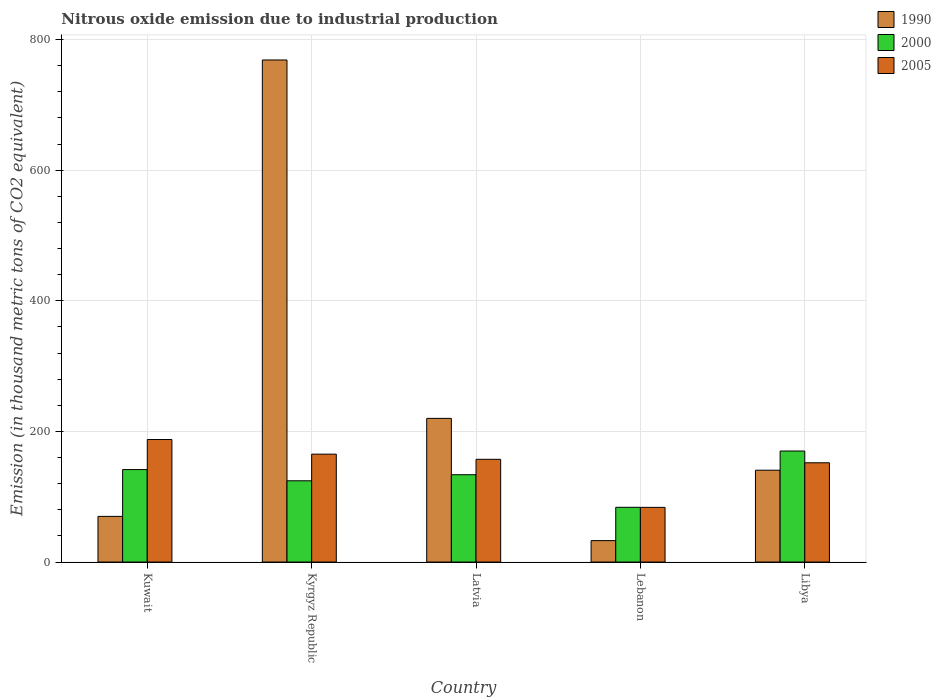Are the number of bars per tick equal to the number of legend labels?
Your answer should be compact. Yes. How many bars are there on the 3rd tick from the left?
Your answer should be very brief. 3. What is the label of the 1st group of bars from the left?
Offer a very short reply. Kuwait. What is the amount of nitrous oxide emitted in 1990 in Latvia?
Your answer should be very brief. 220. Across all countries, what is the maximum amount of nitrous oxide emitted in 1990?
Provide a succinct answer. 768.8. Across all countries, what is the minimum amount of nitrous oxide emitted in 2005?
Ensure brevity in your answer.  83.7. In which country was the amount of nitrous oxide emitted in 2005 maximum?
Give a very brief answer. Kuwait. In which country was the amount of nitrous oxide emitted in 2000 minimum?
Provide a short and direct response. Lebanon. What is the total amount of nitrous oxide emitted in 2005 in the graph?
Your answer should be compact. 745.8. What is the difference between the amount of nitrous oxide emitted in 2005 in Kyrgyz Republic and that in Lebanon?
Give a very brief answer. 81.5. What is the difference between the amount of nitrous oxide emitted in 2005 in Kyrgyz Republic and the amount of nitrous oxide emitted in 2000 in Kuwait?
Ensure brevity in your answer.  23.6. What is the average amount of nitrous oxide emitted in 2005 per country?
Give a very brief answer. 149.16. What is the difference between the amount of nitrous oxide emitted of/in 1990 and amount of nitrous oxide emitted of/in 2005 in Lebanon?
Your response must be concise. -50.9. What is the ratio of the amount of nitrous oxide emitted in 2000 in Kuwait to that in Kyrgyz Republic?
Make the answer very short. 1.14. What is the difference between the highest and the second highest amount of nitrous oxide emitted in 2000?
Offer a very short reply. 28.4. What is the difference between the highest and the lowest amount of nitrous oxide emitted in 2005?
Offer a terse response. 103.9. What does the 3rd bar from the left in Libya represents?
Your answer should be very brief. 2005. What does the 3rd bar from the right in Kuwait represents?
Provide a succinct answer. 1990. What is the difference between two consecutive major ticks on the Y-axis?
Provide a short and direct response. 200. Does the graph contain grids?
Offer a very short reply. Yes. What is the title of the graph?
Your answer should be compact. Nitrous oxide emission due to industrial production. What is the label or title of the Y-axis?
Your answer should be compact. Emission (in thousand metric tons of CO2 equivalent). What is the Emission (in thousand metric tons of CO2 equivalent) of 1990 in Kuwait?
Your answer should be compact. 69.9. What is the Emission (in thousand metric tons of CO2 equivalent) of 2000 in Kuwait?
Your answer should be compact. 141.6. What is the Emission (in thousand metric tons of CO2 equivalent) in 2005 in Kuwait?
Make the answer very short. 187.6. What is the Emission (in thousand metric tons of CO2 equivalent) in 1990 in Kyrgyz Republic?
Make the answer very short. 768.8. What is the Emission (in thousand metric tons of CO2 equivalent) of 2000 in Kyrgyz Republic?
Provide a succinct answer. 124.4. What is the Emission (in thousand metric tons of CO2 equivalent) of 2005 in Kyrgyz Republic?
Your answer should be very brief. 165.2. What is the Emission (in thousand metric tons of CO2 equivalent) in 1990 in Latvia?
Offer a terse response. 220. What is the Emission (in thousand metric tons of CO2 equivalent) of 2000 in Latvia?
Provide a succinct answer. 133.7. What is the Emission (in thousand metric tons of CO2 equivalent) of 2005 in Latvia?
Offer a very short reply. 157.3. What is the Emission (in thousand metric tons of CO2 equivalent) in 1990 in Lebanon?
Offer a very short reply. 32.8. What is the Emission (in thousand metric tons of CO2 equivalent) of 2000 in Lebanon?
Your answer should be compact. 83.8. What is the Emission (in thousand metric tons of CO2 equivalent) of 2005 in Lebanon?
Provide a short and direct response. 83.7. What is the Emission (in thousand metric tons of CO2 equivalent) in 1990 in Libya?
Keep it short and to the point. 140.6. What is the Emission (in thousand metric tons of CO2 equivalent) in 2000 in Libya?
Ensure brevity in your answer.  170. What is the Emission (in thousand metric tons of CO2 equivalent) in 2005 in Libya?
Your response must be concise. 152. Across all countries, what is the maximum Emission (in thousand metric tons of CO2 equivalent) of 1990?
Provide a short and direct response. 768.8. Across all countries, what is the maximum Emission (in thousand metric tons of CO2 equivalent) of 2000?
Your response must be concise. 170. Across all countries, what is the maximum Emission (in thousand metric tons of CO2 equivalent) in 2005?
Keep it short and to the point. 187.6. Across all countries, what is the minimum Emission (in thousand metric tons of CO2 equivalent) in 1990?
Your answer should be very brief. 32.8. Across all countries, what is the minimum Emission (in thousand metric tons of CO2 equivalent) in 2000?
Ensure brevity in your answer.  83.8. Across all countries, what is the minimum Emission (in thousand metric tons of CO2 equivalent) in 2005?
Ensure brevity in your answer.  83.7. What is the total Emission (in thousand metric tons of CO2 equivalent) in 1990 in the graph?
Offer a very short reply. 1232.1. What is the total Emission (in thousand metric tons of CO2 equivalent) of 2000 in the graph?
Your answer should be very brief. 653.5. What is the total Emission (in thousand metric tons of CO2 equivalent) in 2005 in the graph?
Provide a short and direct response. 745.8. What is the difference between the Emission (in thousand metric tons of CO2 equivalent) in 1990 in Kuwait and that in Kyrgyz Republic?
Make the answer very short. -698.9. What is the difference between the Emission (in thousand metric tons of CO2 equivalent) of 2000 in Kuwait and that in Kyrgyz Republic?
Offer a terse response. 17.2. What is the difference between the Emission (in thousand metric tons of CO2 equivalent) in 2005 in Kuwait and that in Kyrgyz Republic?
Provide a short and direct response. 22.4. What is the difference between the Emission (in thousand metric tons of CO2 equivalent) of 1990 in Kuwait and that in Latvia?
Your response must be concise. -150.1. What is the difference between the Emission (in thousand metric tons of CO2 equivalent) of 2000 in Kuwait and that in Latvia?
Ensure brevity in your answer.  7.9. What is the difference between the Emission (in thousand metric tons of CO2 equivalent) in 2005 in Kuwait and that in Latvia?
Your answer should be very brief. 30.3. What is the difference between the Emission (in thousand metric tons of CO2 equivalent) of 1990 in Kuwait and that in Lebanon?
Provide a short and direct response. 37.1. What is the difference between the Emission (in thousand metric tons of CO2 equivalent) of 2000 in Kuwait and that in Lebanon?
Offer a terse response. 57.8. What is the difference between the Emission (in thousand metric tons of CO2 equivalent) in 2005 in Kuwait and that in Lebanon?
Ensure brevity in your answer.  103.9. What is the difference between the Emission (in thousand metric tons of CO2 equivalent) of 1990 in Kuwait and that in Libya?
Keep it short and to the point. -70.7. What is the difference between the Emission (in thousand metric tons of CO2 equivalent) in 2000 in Kuwait and that in Libya?
Offer a very short reply. -28.4. What is the difference between the Emission (in thousand metric tons of CO2 equivalent) in 2005 in Kuwait and that in Libya?
Your answer should be compact. 35.6. What is the difference between the Emission (in thousand metric tons of CO2 equivalent) of 1990 in Kyrgyz Republic and that in Latvia?
Keep it short and to the point. 548.8. What is the difference between the Emission (in thousand metric tons of CO2 equivalent) of 2005 in Kyrgyz Republic and that in Latvia?
Provide a short and direct response. 7.9. What is the difference between the Emission (in thousand metric tons of CO2 equivalent) of 1990 in Kyrgyz Republic and that in Lebanon?
Offer a very short reply. 736. What is the difference between the Emission (in thousand metric tons of CO2 equivalent) of 2000 in Kyrgyz Republic and that in Lebanon?
Provide a succinct answer. 40.6. What is the difference between the Emission (in thousand metric tons of CO2 equivalent) in 2005 in Kyrgyz Republic and that in Lebanon?
Give a very brief answer. 81.5. What is the difference between the Emission (in thousand metric tons of CO2 equivalent) in 1990 in Kyrgyz Republic and that in Libya?
Offer a very short reply. 628.2. What is the difference between the Emission (in thousand metric tons of CO2 equivalent) in 2000 in Kyrgyz Republic and that in Libya?
Make the answer very short. -45.6. What is the difference between the Emission (in thousand metric tons of CO2 equivalent) of 2005 in Kyrgyz Republic and that in Libya?
Your answer should be very brief. 13.2. What is the difference between the Emission (in thousand metric tons of CO2 equivalent) in 1990 in Latvia and that in Lebanon?
Your answer should be very brief. 187.2. What is the difference between the Emission (in thousand metric tons of CO2 equivalent) of 2000 in Latvia and that in Lebanon?
Provide a short and direct response. 49.9. What is the difference between the Emission (in thousand metric tons of CO2 equivalent) of 2005 in Latvia and that in Lebanon?
Provide a short and direct response. 73.6. What is the difference between the Emission (in thousand metric tons of CO2 equivalent) in 1990 in Latvia and that in Libya?
Provide a succinct answer. 79.4. What is the difference between the Emission (in thousand metric tons of CO2 equivalent) of 2000 in Latvia and that in Libya?
Your answer should be compact. -36.3. What is the difference between the Emission (in thousand metric tons of CO2 equivalent) in 2005 in Latvia and that in Libya?
Your answer should be compact. 5.3. What is the difference between the Emission (in thousand metric tons of CO2 equivalent) of 1990 in Lebanon and that in Libya?
Ensure brevity in your answer.  -107.8. What is the difference between the Emission (in thousand metric tons of CO2 equivalent) of 2000 in Lebanon and that in Libya?
Make the answer very short. -86.2. What is the difference between the Emission (in thousand metric tons of CO2 equivalent) in 2005 in Lebanon and that in Libya?
Offer a very short reply. -68.3. What is the difference between the Emission (in thousand metric tons of CO2 equivalent) in 1990 in Kuwait and the Emission (in thousand metric tons of CO2 equivalent) in 2000 in Kyrgyz Republic?
Your response must be concise. -54.5. What is the difference between the Emission (in thousand metric tons of CO2 equivalent) in 1990 in Kuwait and the Emission (in thousand metric tons of CO2 equivalent) in 2005 in Kyrgyz Republic?
Your answer should be very brief. -95.3. What is the difference between the Emission (in thousand metric tons of CO2 equivalent) in 2000 in Kuwait and the Emission (in thousand metric tons of CO2 equivalent) in 2005 in Kyrgyz Republic?
Provide a short and direct response. -23.6. What is the difference between the Emission (in thousand metric tons of CO2 equivalent) in 1990 in Kuwait and the Emission (in thousand metric tons of CO2 equivalent) in 2000 in Latvia?
Provide a short and direct response. -63.8. What is the difference between the Emission (in thousand metric tons of CO2 equivalent) in 1990 in Kuwait and the Emission (in thousand metric tons of CO2 equivalent) in 2005 in Latvia?
Your response must be concise. -87.4. What is the difference between the Emission (in thousand metric tons of CO2 equivalent) of 2000 in Kuwait and the Emission (in thousand metric tons of CO2 equivalent) of 2005 in Latvia?
Offer a very short reply. -15.7. What is the difference between the Emission (in thousand metric tons of CO2 equivalent) in 1990 in Kuwait and the Emission (in thousand metric tons of CO2 equivalent) in 2005 in Lebanon?
Keep it short and to the point. -13.8. What is the difference between the Emission (in thousand metric tons of CO2 equivalent) in 2000 in Kuwait and the Emission (in thousand metric tons of CO2 equivalent) in 2005 in Lebanon?
Your response must be concise. 57.9. What is the difference between the Emission (in thousand metric tons of CO2 equivalent) of 1990 in Kuwait and the Emission (in thousand metric tons of CO2 equivalent) of 2000 in Libya?
Give a very brief answer. -100.1. What is the difference between the Emission (in thousand metric tons of CO2 equivalent) of 1990 in Kuwait and the Emission (in thousand metric tons of CO2 equivalent) of 2005 in Libya?
Your answer should be compact. -82.1. What is the difference between the Emission (in thousand metric tons of CO2 equivalent) in 1990 in Kyrgyz Republic and the Emission (in thousand metric tons of CO2 equivalent) in 2000 in Latvia?
Ensure brevity in your answer.  635.1. What is the difference between the Emission (in thousand metric tons of CO2 equivalent) in 1990 in Kyrgyz Republic and the Emission (in thousand metric tons of CO2 equivalent) in 2005 in Latvia?
Provide a succinct answer. 611.5. What is the difference between the Emission (in thousand metric tons of CO2 equivalent) in 2000 in Kyrgyz Republic and the Emission (in thousand metric tons of CO2 equivalent) in 2005 in Latvia?
Your answer should be compact. -32.9. What is the difference between the Emission (in thousand metric tons of CO2 equivalent) in 1990 in Kyrgyz Republic and the Emission (in thousand metric tons of CO2 equivalent) in 2000 in Lebanon?
Ensure brevity in your answer.  685. What is the difference between the Emission (in thousand metric tons of CO2 equivalent) in 1990 in Kyrgyz Republic and the Emission (in thousand metric tons of CO2 equivalent) in 2005 in Lebanon?
Give a very brief answer. 685.1. What is the difference between the Emission (in thousand metric tons of CO2 equivalent) of 2000 in Kyrgyz Republic and the Emission (in thousand metric tons of CO2 equivalent) of 2005 in Lebanon?
Your response must be concise. 40.7. What is the difference between the Emission (in thousand metric tons of CO2 equivalent) of 1990 in Kyrgyz Republic and the Emission (in thousand metric tons of CO2 equivalent) of 2000 in Libya?
Give a very brief answer. 598.8. What is the difference between the Emission (in thousand metric tons of CO2 equivalent) of 1990 in Kyrgyz Republic and the Emission (in thousand metric tons of CO2 equivalent) of 2005 in Libya?
Give a very brief answer. 616.8. What is the difference between the Emission (in thousand metric tons of CO2 equivalent) in 2000 in Kyrgyz Republic and the Emission (in thousand metric tons of CO2 equivalent) in 2005 in Libya?
Give a very brief answer. -27.6. What is the difference between the Emission (in thousand metric tons of CO2 equivalent) of 1990 in Latvia and the Emission (in thousand metric tons of CO2 equivalent) of 2000 in Lebanon?
Your answer should be very brief. 136.2. What is the difference between the Emission (in thousand metric tons of CO2 equivalent) of 1990 in Latvia and the Emission (in thousand metric tons of CO2 equivalent) of 2005 in Lebanon?
Provide a short and direct response. 136.3. What is the difference between the Emission (in thousand metric tons of CO2 equivalent) of 1990 in Latvia and the Emission (in thousand metric tons of CO2 equivalent) of 2000 in Libya?
Keep it short and to the point. 50. What is the difference between the Emission (in thousand metric tons of CO2 equivalent) in 2000 in Latvia and the Emission (in thousand metric tons of CO2 equivalent) in 2005 in Libya?
Make the answer very short. -18.3. What is the difference between the Emission (in thousand metric tons of CO2 equivalent) in 1990 in Lebanon and the Emission (in thousand metric tons of CO2 equivalent) in 2000 in Libya?
Make the answer very short. -137.2. What is the difference between the Emission (in thousand metric tons of CO2 equivalent) in 1990 in Lebanon and the Emission (in thousand metric tons of CO2 equivalent) in 2005 in Libya?
Your response must be concise. -119.2. What is the difference between the Emission (in thousand metric tons of CO2 equivalent) of 2000 in Lebanon and the Emission (in thousand metric tons of CO2 equivalent) of 2005 in Libya?
Offer a terse response. -68.2. What is the average Emission (in thousand metric tons of CO2 equivalent) of 1990 per country?
Offer a terse response. 246.42. What is the average Emission (in thousand metric tons of CO2 equivalent) of 2000 per country?
Keep it short and to the point. 130.7. What is the average Emission (in thousand metric tons of CO2 equivalent) of 2005 per country?
Provide a short and direct response. 149.16. What is the difference between the Emission (in thousand metric tons of CO2 equivalent) in 1990 and Emission (in thousand metric tons of CO2 equivalent) in 2000 in Kuwait?
Give a very brief answer. -71.7. What is the difference between the Emission (in thousand metric tons of CO2 equivalent) of 1990 and Emission (in thousand metric tons of CO2 equivalent) of 2005 in Kuwait?
Provide a succinct answer. -117.7. What is the difference between the Emission (in thousand metric tons of CO2 equivalent) of 2000 and Emission (in thousand metric tons of CO2 equivalent) of 2005 in Kuwait?
Offer a terse response. -46. What is the difference between the Emission (in thousand metric tons of CO2 equivalent) in 1990 and Emission (in thousand metric tons of CO2 equivalent) in 2000 in Kyrgyz Republic?
Offer a terse response. 644.4. What is the difference between the Emission (in thousand metric tons of CO2 equivalent) in 1990 and Emission (in thousand metric tons of CO2 equivalent) in 2005 in Kyrgyz Republic?
Your answer should be compact. 603.6. What is the difference between the Emission (in thousand metric tons of CO2 equivalent) in 2000 and Emission (in thousand metric tons of CO2 equivalent) in 2005 in Kyrgyz Republic?
Offer a terse response. -40.8. What is the difference between the Emission (in thousand metric tons of CO2 equivalent) of 1990 and Emission (in thousand metric tons of CO2 equivalent) of 2000 in Latvia?
Offer a very short reply. 86.3. What is the difference between the Emission (in thousand metric tons of CO2 equivalent) in 1990 and Emission (in thousand metric tons of CO2 equivalent) in 2005 in Latvia?
Your response must be concise. 62.7. What is the difference between the Emission (in thousand metric tons of CO2 equivalent) of 2000 and Emission (in thousand metric tons of CO2 equivalent) of 2005 in Latvia?
Your answer should be very brief. -23.6. What is the difference between the Emission (in thousand metric tons of CO2 equivalent) of 1990 and Emission (in thousand metric tons of CO2 equivalent) of 2000 in Lebanon?
Your answer should be very brief. -51. What is the difference between the Emission (in thousand metric tons of CO2 equivalent) of 1990 and Emission (in thousand metric tons of CO2 equivalent) of 2005 in Lebanon?
Ensure brevity in your answer.  -50.9. What is the difference between the Emission (in thousand metric tons of CO2 equivalent) of 2000 and Emission (in thousand metric tons of CO2 equivalent) of 2005 in Lebanon?
Ensure brevity in your answer.  0.1. What is the difference between the Emission (in thousand metric tons of CO2 equivalent) of 1990 and Emission (in thousand metric tons of CO2 equivalent) of 2000 in Libya?
Keep it short and to the point. -29.4. What is the ratio of the Emission (in thousand metric tons of CO2 equivalent) of 1990 in Kuwait to that in Kyrgyz Republic?
Your response must be concise. 0.09. What is the ratio of the Emission (in thousand metric tons of CO2 equivalent) in 2000 in Kuwait to that in Kyrgyz Republic?
Provide a short and direct response. 1.14. What is the ratio of the Emission (in thousand metric tons of CO2 equivalent) of 2005 in Kuwait to that in Kyrgyz Republic?
Ensure brevity in your answer.  1.14. What is the ratio of the Emission (in thousand metric tons of CO2 equivalent) of 1990 in Kuwait to that in Latvia?
Your answer should be very brief. 0.32. What is the ratio of the Emission (in thousand metric tons of CO2 equivalent) of 2000 in Kuwait to that in Latvia?
Make the answer very short. 1.06. What is the ratio of the Emission (in thousand metric tons of CO2 equivalent) of 2005 in Kuwait to that in Latvia?
Make the answer very short. 1.19. What is the ratio of the Emission (in thousand metric tons of CO2 equivalent) of 1990 in Kuwait to that in Lebanon?
Make the answer very short. 2.13. What is the ratio of the Emission (in thousand metric tons of CO2 equivalent) of 2000 in Kuwait to that in Lebanon?
Provide a succinct answer. 1.69. What is the ratio of the Emission (in thousand metric tons of CO2 equivalent) of 2005 in Kuwait to that in Lebanon?
Ensure brevity in your answer.  2.24. What is the ratio of the Emission (in thousand metric tons of CO2 equivalent) of 1990 in Kuwait to that in Libya?
Ensure brevity in your answer.  0.5. What is the ratio of the Emission (in thousand metric tons of CO2 equivalent) in 2000 in Kuwait to that in Libya?
Keep it short and to the point. 0.83. What is the ratio of the Emission (in thousand metric tons of CO2 equivalent) in 2005 in Kuwait to that in Libya?
Ensure brevity in your answer.  1.23. What is the ratio of the Emission (in thousand metric tons of CO2 equivalent) of 1990 in Kyrgyz Republic to that in Latvia?
Make the answer very short. 3.49. What is the ratio of the Emission (in thousand metric tons of CO2 equivalent) of 2000 in Kyrgyz Republic to that in Latvia?
Offer a terse response. 0.93. What is the ratio of the Emission (in thousand metric tons of CO2 equivalent) of 2005 in Kyrgyz Republic to that in Latvia?
Your answer should be very brief. 1.05. What is the ratio of the Emission (in thousand metric tons of CO2 equivalent) in 1990 in Kyrgyz Republic to that in Lebanon?
Keep it short and to the point. 23.44. What is the ratio of the Emission (in thousand metric tons of CO2 equivalent) of 2000 in Kyrgyz Republic to that in Lebanon?
Keep it short and to the point. 1.48. What is the ratio of the Emission (in thousand metric tons of CO2 equivalent) in 2005 in Kyrgyz Republic to that in Lebanon?
Offer a terse response. 1.97. What is the ratio of the Emission (in thousand metric tons of CO2 equivalent) in 1990 in Kyrgyz Republic to that in Libya?
Keep it short and to the point. 5.47. What is the ratio of the Emission (in thousand metric tons of CO2 equivalent) in 2000 in Kyrgyz Republic to that in Libya?
Give a very brief answer. 0.73. What is the ratio of the Emission (in thousand metric tons of CO2 equivalent) of 2005 in Kyrgyz Republic to that in Libya?
Your answer should be very brief. 1.09. What is the ratio of the Emission (in thousand metric tons of CO2 equivalent) in 1990 in Latvia to that in Lebanon?
Offer a terse response. 6.71. What is the ratio of the Emission (in thousand metric tons of CO2 equivalent) of 2000 in Latvia to that in Lebanon?
Give a very brief answer. 1.6. What is the ratio of the Emission (in thousand metric tons of CO2 equivalent) in 2005 in Latvia to that in Lebanon?
Give a very brief answer. 1.88. What is the ratio of the Emission (in thousand metric tons of CO2 equivalent) in 1990 in Latvia to that in Libya?
Provide a succinct answer. 1.56. What is the ratio of the Emission (in thousand metric tons of CO2 equivalent) of 2000 in Latvia to that in Libya?
Your response must be concise. 0.79. What is the ratio of the Emission (in thousand metric tons of CO2 equivalent) in 2005 in Latvia to that in Libya?
Provide a short and direct response. 1.03. What is the ratio of the Emission (in thousand metric tons of CO2 equivalent) of 1990 in Lebanon to that in Libya?
Offer a terse response. 0.23. What is the ratio of the Emission (in thousand metric tons of CO2 equivalent) of 2000 in Lebanon to that in Libya?
Your response must be concise. 0.49. What is the ratio of the Emission (in thousand metric tons of CO2 equivalent) of 2005 in Lebanon to that in Libya?
Your answer should be compact. 0.55. What is the difference between the highest and the second highest Emission (in thousand metric tons of CO2 equivalent) in 1990?
Provide a succinct answer. 548.8. What is the difference between the highest and the second highest Emission (in thousand metric tons of CO2 equivalent) of 2000?
Provide a succinct answer. 28.4. What is the difference between the highest and the second highest Emission (in thousand metric tons of CO2 equivalent) in 2005?
Provide a succinct answer. 22.4. What is the difference between the highest and the lowest Emission (in thousand metric tons of CO2 equivalent) in 1990?
Make the answer very short. 736. What is the difference between the highest and the lowest Emission (in thousand metric tons of CO2 equivalent) in 2000?
Make the answer very short. 86.2. What is the difference between the highest and the lowest Emission (in thousand metric tons of CO2 equivalent) of 2005?
Keep it short and to the point. 103.9. 